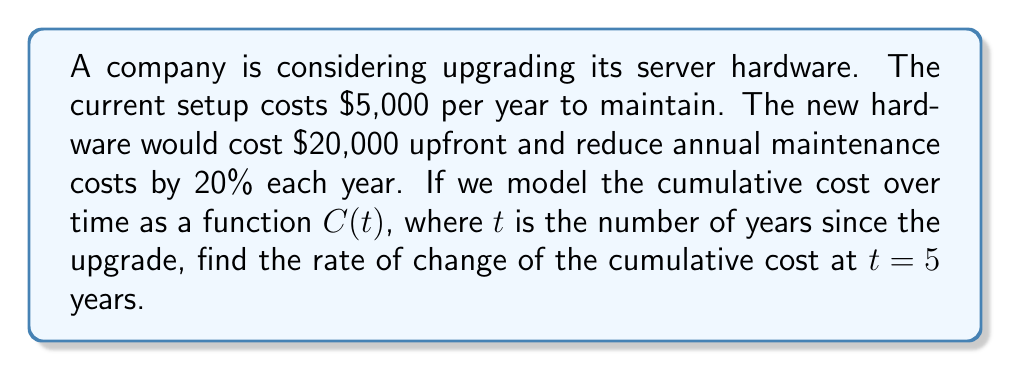Help me with this question. Let's approach this step-by-step:

1) First, we need to formulate the cumulative cost function $C(t)$:
   - Initial cost: $20,000
   - Annual maintenance cost: $5,000 * (0.8)^t$ (20% reduction each year)
   - Cumulative cost: $C(t) = 20000 + \int_0^t 5000 * (0.8)^x dx$

2) To solve the integral:
   $$C(t) = 20000 + 5000 * \frac{(0.8)^t - 1}{\ln(0.8)}$$

3) To find the rate of change, we need to differentiate $C(t)$ with respect to $t$:
   $$C'(t) = 5000 * \frac{(0.8)^t * \ln(0.8)}{\ln(0.8)} = 5000 * (0.8)^t$$

4) Now, we evaluate $C'(t)$ at $t = 5$:
   $$C'(5) = 5000 * (0.8)^5 = 5000 * 0.32768 = 1638.4$$

Therefore, the rate of change of the cumulative cost at $t = 5$ years is $1638.4 per year.
Answer: $1638.4 per year 